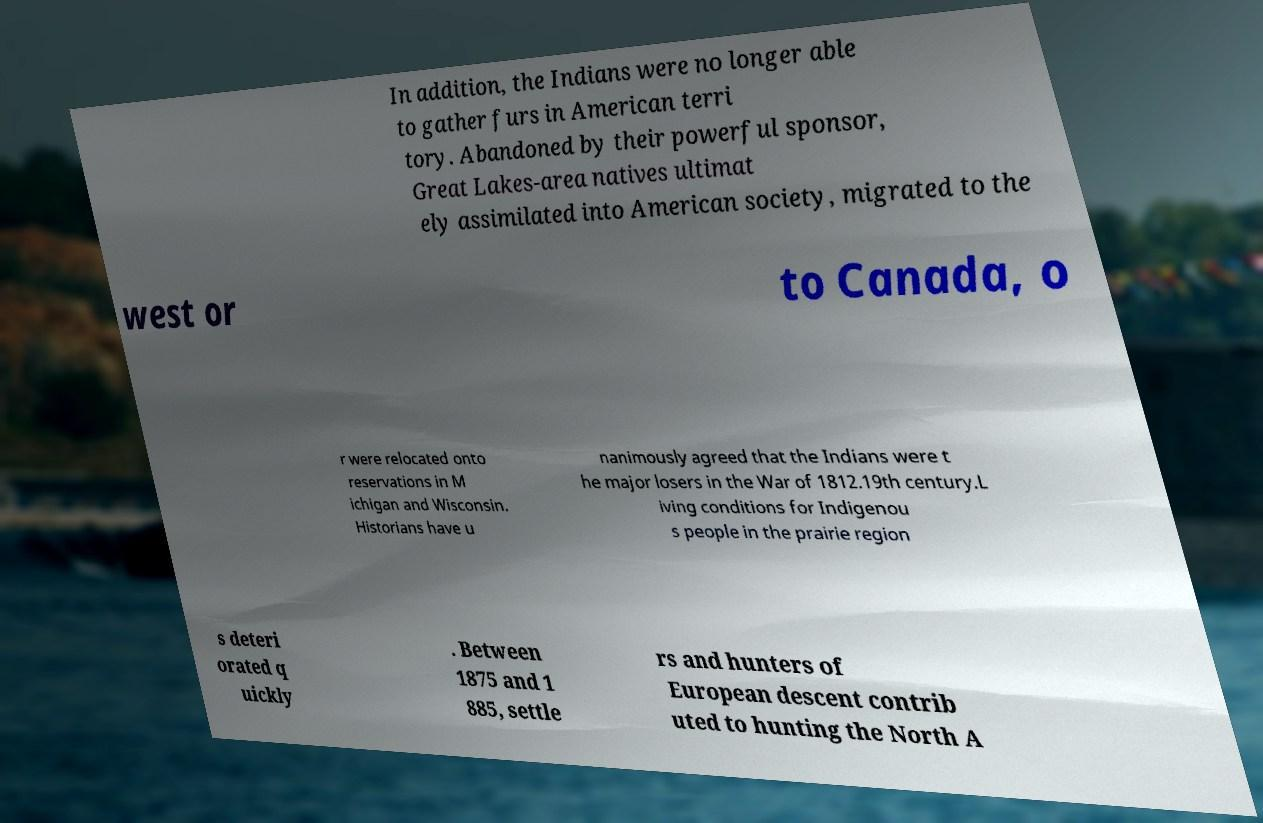Can you accurately transcribe the text from the provided image for me? In addition, the Indians were no longer able to gather furs in American terri tory. Abandoned by their powerful sponsor, Great Lakes-area natives ultimat ely assimilated into American society, migrated to the west or to Canada, o r were relocated onto reservations in M ichigan and Wisconsin. Historians have u nanimously agreed that the Indians were t he major losers in the War of 1812.19th century.L iving conditions for Indigenou s people in the prairie region s deteri orated q uickly . Between 1875 and 1 885, settle rs and hunters of European descent contrib uted to hunting the North A 